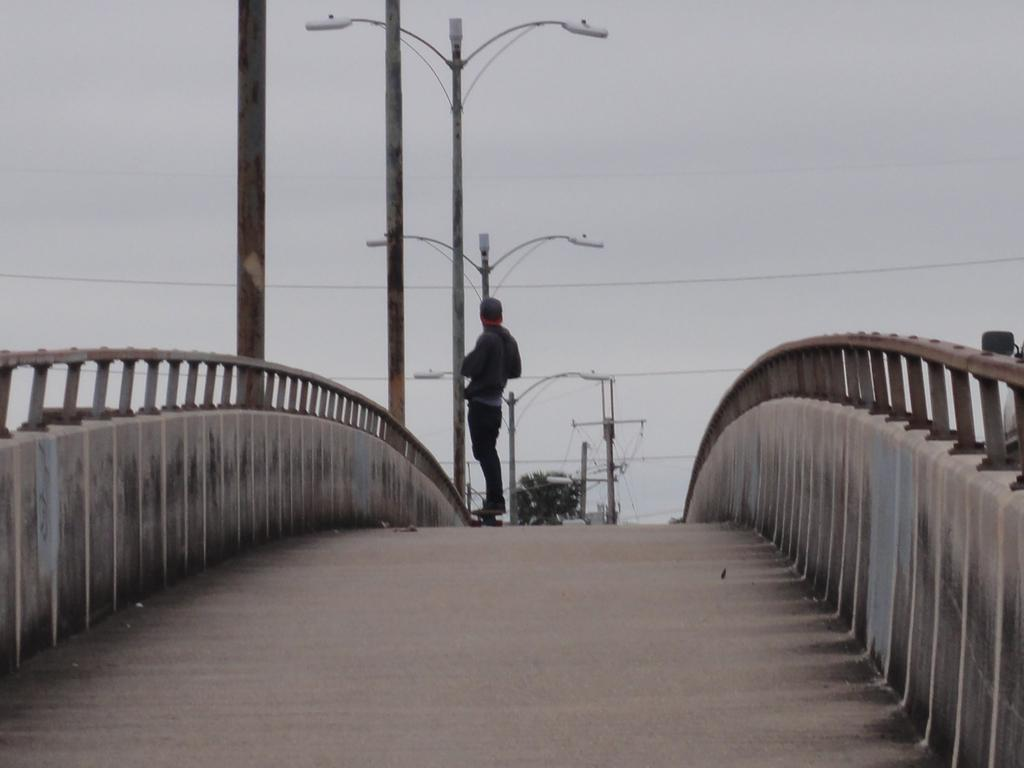What can be seen in the image that people walk on? There is a path in the image that people can walk on. Can you describe the person in the image? There is a person standing in the image. What structures are present to provide light in the image? Light poles are visible in the image. What is visible in the background of the image? The sky is visible in the background of the image. What else can be seen in the background of the image? Wires are present in the background of the image. How many frogs are sitting on the canvas in the image? There is no canvas or frogs present in the image. What type of animal can be seen interacting with the person in the image? There are no animals present in the image; only the person and the path are visible. 